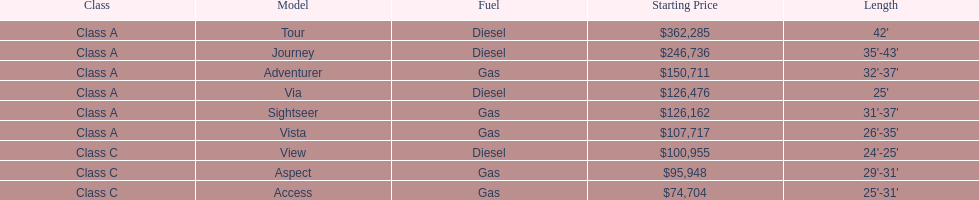What is the total number of class a models? 6. 